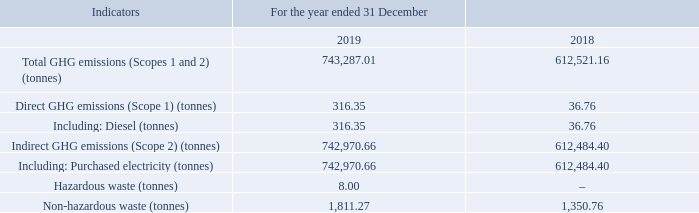1.2 Data Centres
Note: 1. Due to its business nature, the significant air emissions of the Group are GHG emissions, arising mainly from fuels and purchased electricity produced from fossil fuels.
2. The Group’s GHG inventory includes carbon dioxide, methane and nitrous oxide. GHG emissions data for the year ended 31 December 2019 is presented in carbon dioxide equivalent and is calculated based on the “2017 Baseline Emission Factors for Regional Power Grids in China for CDM and CCER Projects” issued by the Ministry of Ecology and Environment of China, and the “2006 IPCC Guidelines for National Greenhouse Gas Inventories” issued by the Intergovernmental Panel on Climate Change (IPCC).
3. Diesel is consumed by backup power generators.
4. Hazardous waste produced by the Group’s office buildings mainly includes waste toner cartridge and waste ink cartridge from printing equipment. Waste toner cartridge and waste ink cartridge are centralised and disposed of by printing suppliers. Such data covers all office buildings of the Group in Mainland China.
5. Non-hazardous waste produced by the Group’s office buildings mainly includes domestic waste and non-hazardous office waste. Domestic waste is disposed of by the property management companies and kitchen waste recycling vendors, and its data is not available, therefore estimation of domestic waste is made with reference to “Handbook on Domestic Discharge Coefficients for Towns in the First Nationwide Census on Contaminant Discharge” published by the State Council. Non-hazardous office waste is centralised for disposal by vendors; hence such data covers all office buildings of the Group in Mainland China.
6. Hazardous waste produced by the Group’s data centres mainly includes waste lead-acid accumulators. Waste lead-acid accumulators are disposed of by qualified waste recycling vendors.
7. Non-hazardous waste produced by the Group’s data centres mainly includes waste servers and waste hard drives. Waste servers and destroyed waste hard drives are centralised and recycled by waste recycling vendors. Such data covers all the Group’s data centres.
Where does the Group's significant air emissions arise from? Fuels and purchased electricity produced from fossil fuel. What does the Group's GHG inventory include? Carbon dioxide, methane and nitrous oxide. What does the hazardous waste produced by the Group's office buildings mainly include? Waste toner cartridge and waste ink cartridge from printing equipment. What is the change between 2018 and 2019 Total GHG emissions in tonnes? 743,287.01-612,521.16
Answer: 130765.85. What is the change between 2018 and 2019 direct GHG emissions in tonnes? 316.35-36.76
Answer: 279.59. What is the change between 2018 and 2019 non-hazardous waste in tonnes? 1,811.27-1,350.76
Answer: 460.51. 